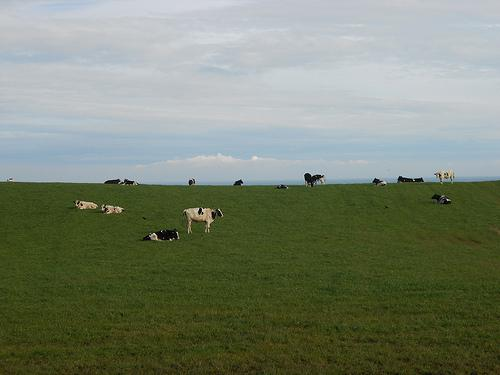Question: when was the photo taken?
Choices:
A. Yesterday.
B. Day time.
C. Earlier today.
D. At noon.
Answer with the letter. Answer: B Question: who is on the grass?
Choices:
A. Cows.
B. Sheep.
C. Chickens.
D. Horses.
Answer with the letter. Answer: A Question: how many cows are there?
Choices:
A. 9.
B. 8.
C. 7.
D. 10.
Answer with the letter. Answer: D Question: what time of day is it?
Choices:
A. Morning.
B. Night.
C. Dawn.
D. Twilight.
Answer with the letter. Answer: A Question: what are the cows doing?
Choices:
A. Lying down.
B. Being milked.
C. Standing.
D. Walking.
Answer with the letter. Answer: C Question: where was the photo taken?
Choices:
A. At a beach.
B. At the train station.
C. On the sidewalk.
D. In a field.
Answer with the letter. Answer: D 